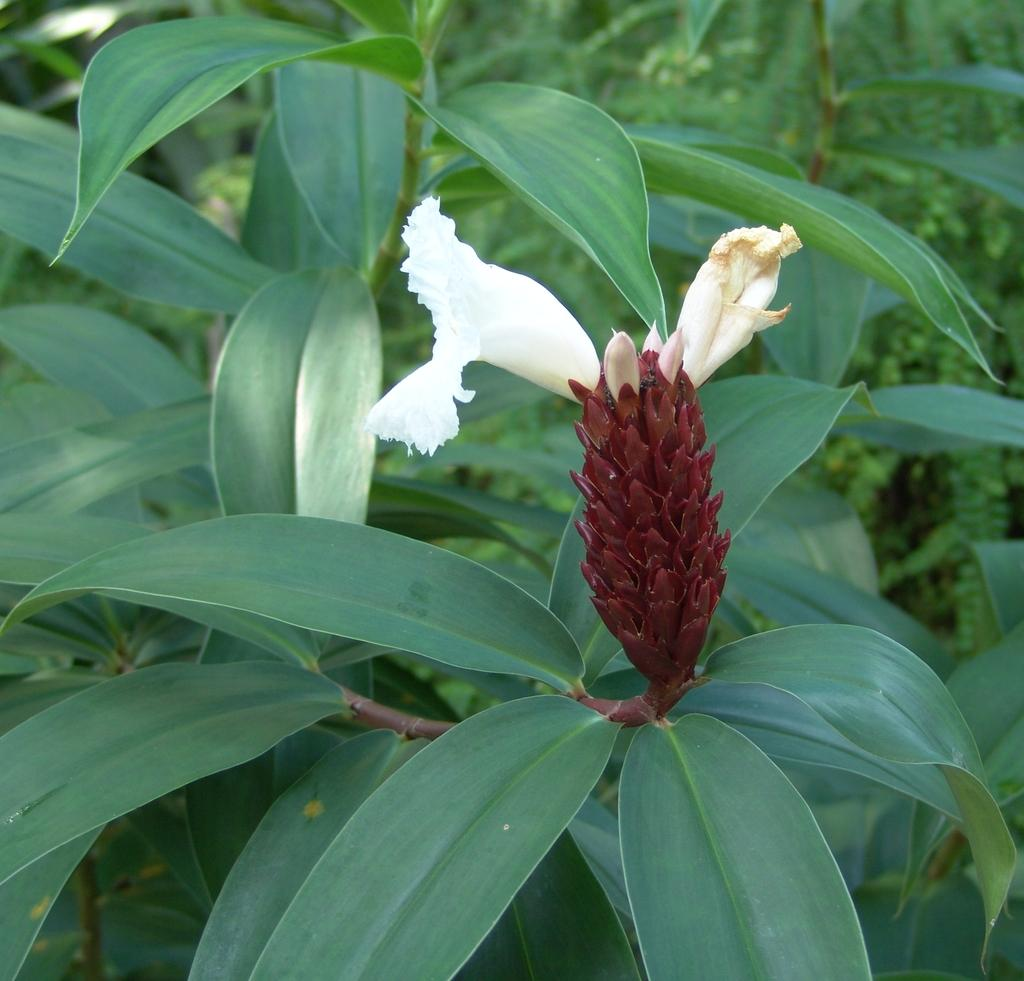What type of plant can be seen in the image? There is a flower in the image. What else is visible on the plant in the image? There are leaves in the image. What can be seen in the background of the image? There are trees in the background of the image. What is the tax rate for the flower in the image? There is no tax rate associated with the flower in the image, as it is a living organism and not subject to taxation. 